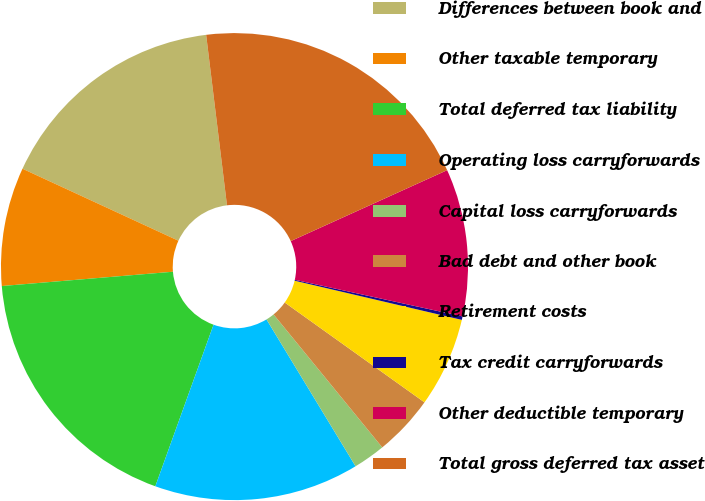Convert chart to OTSL. <chart><loc_0><loc_0><loc_500><loc_500><pie_chart><fcel>Differences between book and<fcel>Other taxable temporary<fcel>Total deferred tax liability<fcel>Operating loss carryforwards<fcel>Capital loss carryforwards<fcel>Bad debt and other book<fcel>Retirement costs<fcel>Tax credit carryforwards<fcel>Other deductible temporary<fcel>Total gross deferred tax asset<nl><fcel>16.18%<fcel>8.21%<fcel>18.17%<fcel>14.18%<fcel>2.23%<fcel>4.22%<fcel>6.21%<fcel>0.24%<fcel>10.2%<fcel>20.16%<nl></chart> 